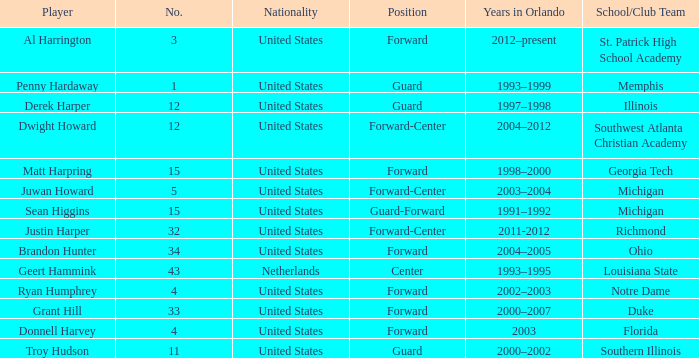What school did Dwight Howard play for Southwest Atlanta Christian Academy. Could you parse the entire table? {'header': ['Player', 'No.', 'Nationality', 'Position', 'Years in Orlando', 'School/Club Team'], 'rows': [['Al Harrington', '3', 'United States', 'Forward', '2012–present', 'St. Patrick High School Academy'], ['Penny Hardaway', '1', 'United States', 'Guard', '1993–1999', 'Memphis'], ['Derek Harper', '12', 'United States', 'Guard', '1997–1998', 'Illinois'], ['Dwight Howard', '12', 'United States', 'Forward-Center', '2004–2012', 'Southwest Atlanta Christian Academy'], ['Matt Harpring', '15', 'United States', 'Forward', '1998–2000', 'Georgia Tech'], ['Juwan Howard', '5', 'United States', 'Forward-Center', '2003–2004', 'Michigan'], ['Sean Higgins', '15', 'United States', 'Guard-Forward', '1991–1992', 'Michigan'], ['Justin Harper', '32', 'United States', 'Forward-Center', '2011-2012', 'Richmond'], ['Brandon Hunter', '34', 'United States', 'Forward', '2004–2005', 'Ohio'], ['Geert Hammink', '43', 'Netherlands', 'Center', '1993–1995', 'Louisiana State'], ['Ryan Humphrey', '4', 'United States', 'Forward', '2002–2003', 'Notre Dame'], ['Grant Hill', '33', 'United States', 'Forward', '2000–2007', 'Duke'], ['Donnell Harvey', '4', 'United States', 'Forward', '2003', 'Florida'], ['Troy Hudson', '11', 'United States', 'Guard', '2000–2002', 'Southern Illinois']]} 